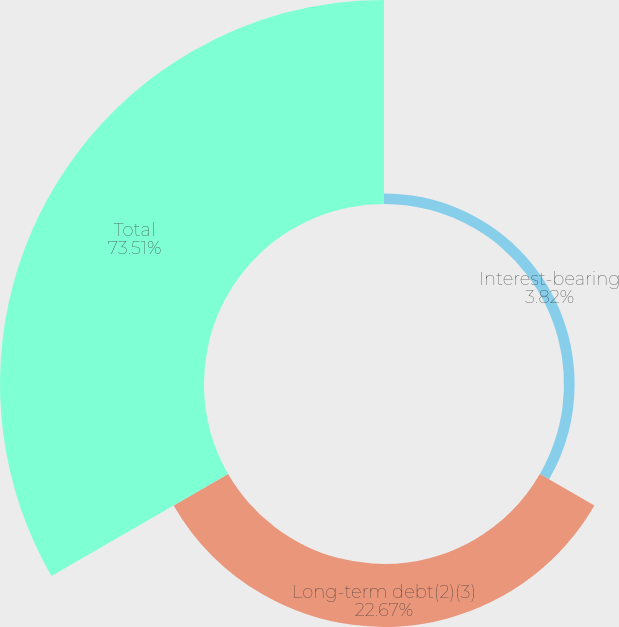Convert chart. <chart><loc_0><loc_0><loc_500><loc_500><pie_chart><fcel>Interest-bearing<fcel>Long-term debt(2)(3)<fcel>Total<nl><fcel>3.82%<fcel>22.67%<fcel>73.51%<nl></chart> 